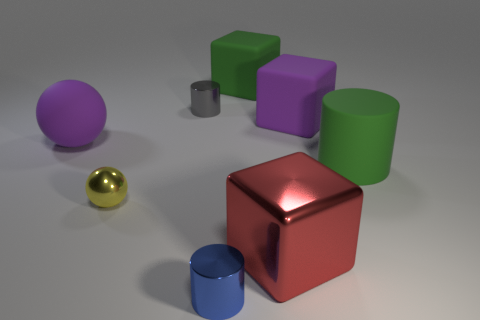What number of things are either big things or big brown matte cubes?
Your answer should be very brief. 5. Are there any big cylinders of the same color as the metallic sphere?
Your response must be concise. No. There is a large rubber object that is on the left side of the yellow shiny ball; how many big rubber balls are in front of it?
Your answer should be very brief. 0. Is the number of small brown balls greater than the number of blue things?
Your answer should be compact. No. Is the blue cylinder made of the same material as the tiny yellow object?
Make the answer very short. Yes. Is the number of red blocks that are behind the big red metal block the same as the number of green rubber things?
Give a very brief answer. No. What number of other large things are the same material as the red object?
Keep it short and to the point. 0. Are there fewer spheres than red metal blocks?
Your answer should be very brief. No. There is a block right of the big red metal object; is it the same color as the rubber sphere?
Give a very brief answer. Yes. How many blue metal cylinders are right of the green object behind the large green object that is in front of the large sphere?
Keep it short and to the point. 0. 